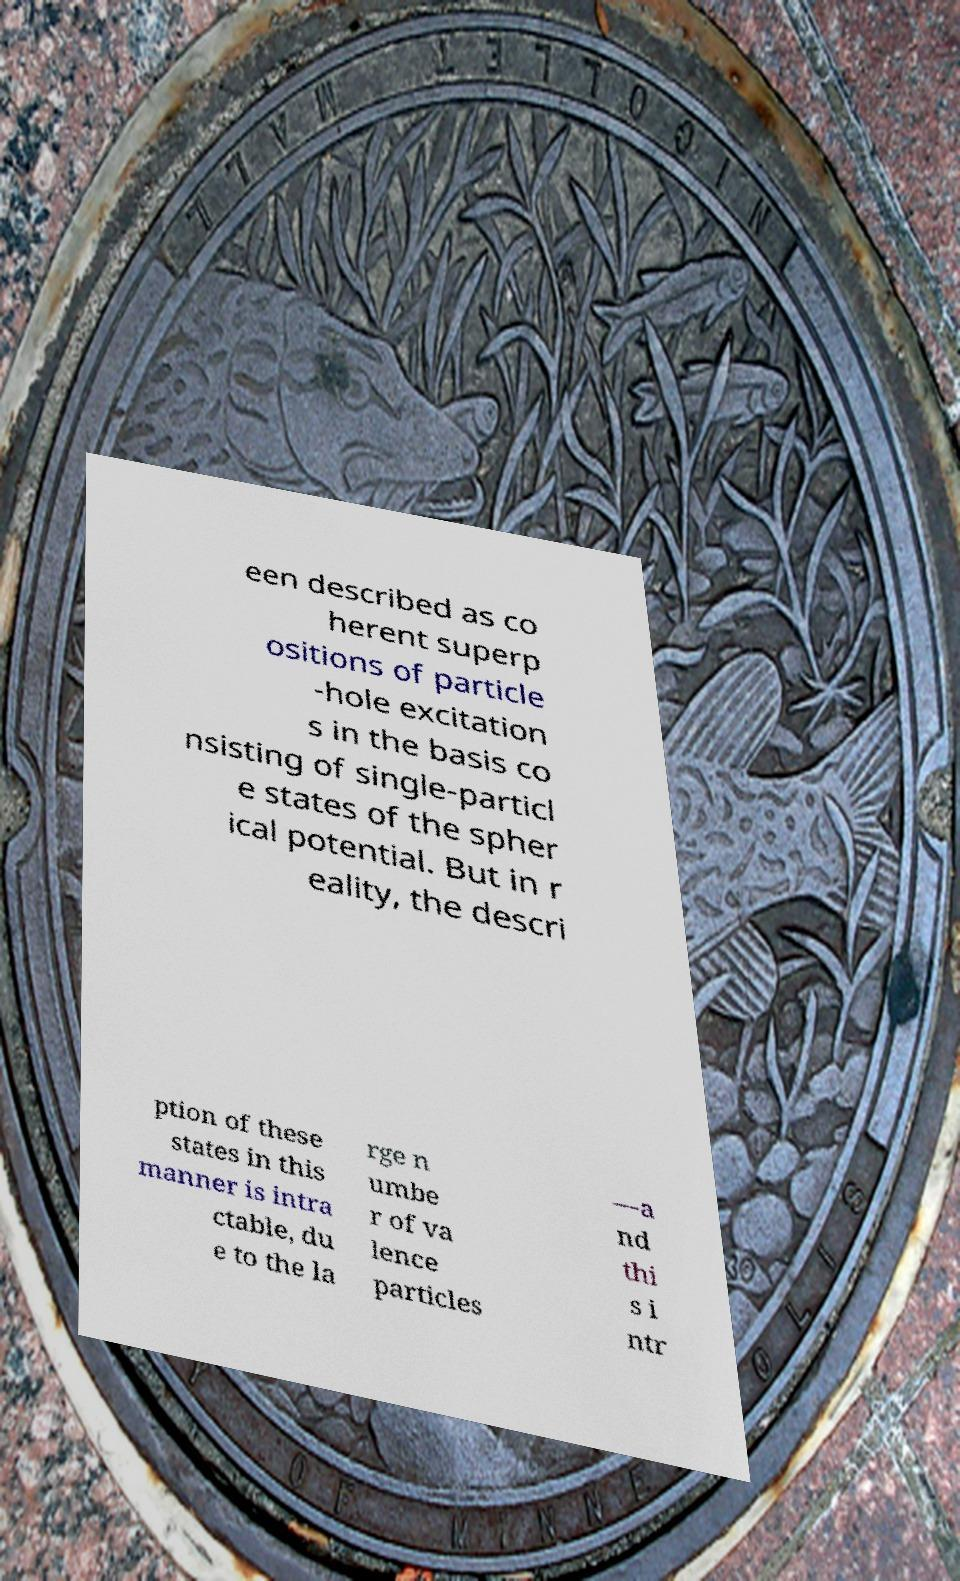Please read and relay the text visible in this image. What does it say? een described as co herent superp ositions of particle -hole excitation s in the basis co nsisting of single-particl e states of the spher ical potential. But in r eality, the descri ption of these states in this manner is intra ctable, du e to the la rge n umbe r of va lence particles —a nd thi s i ntr 